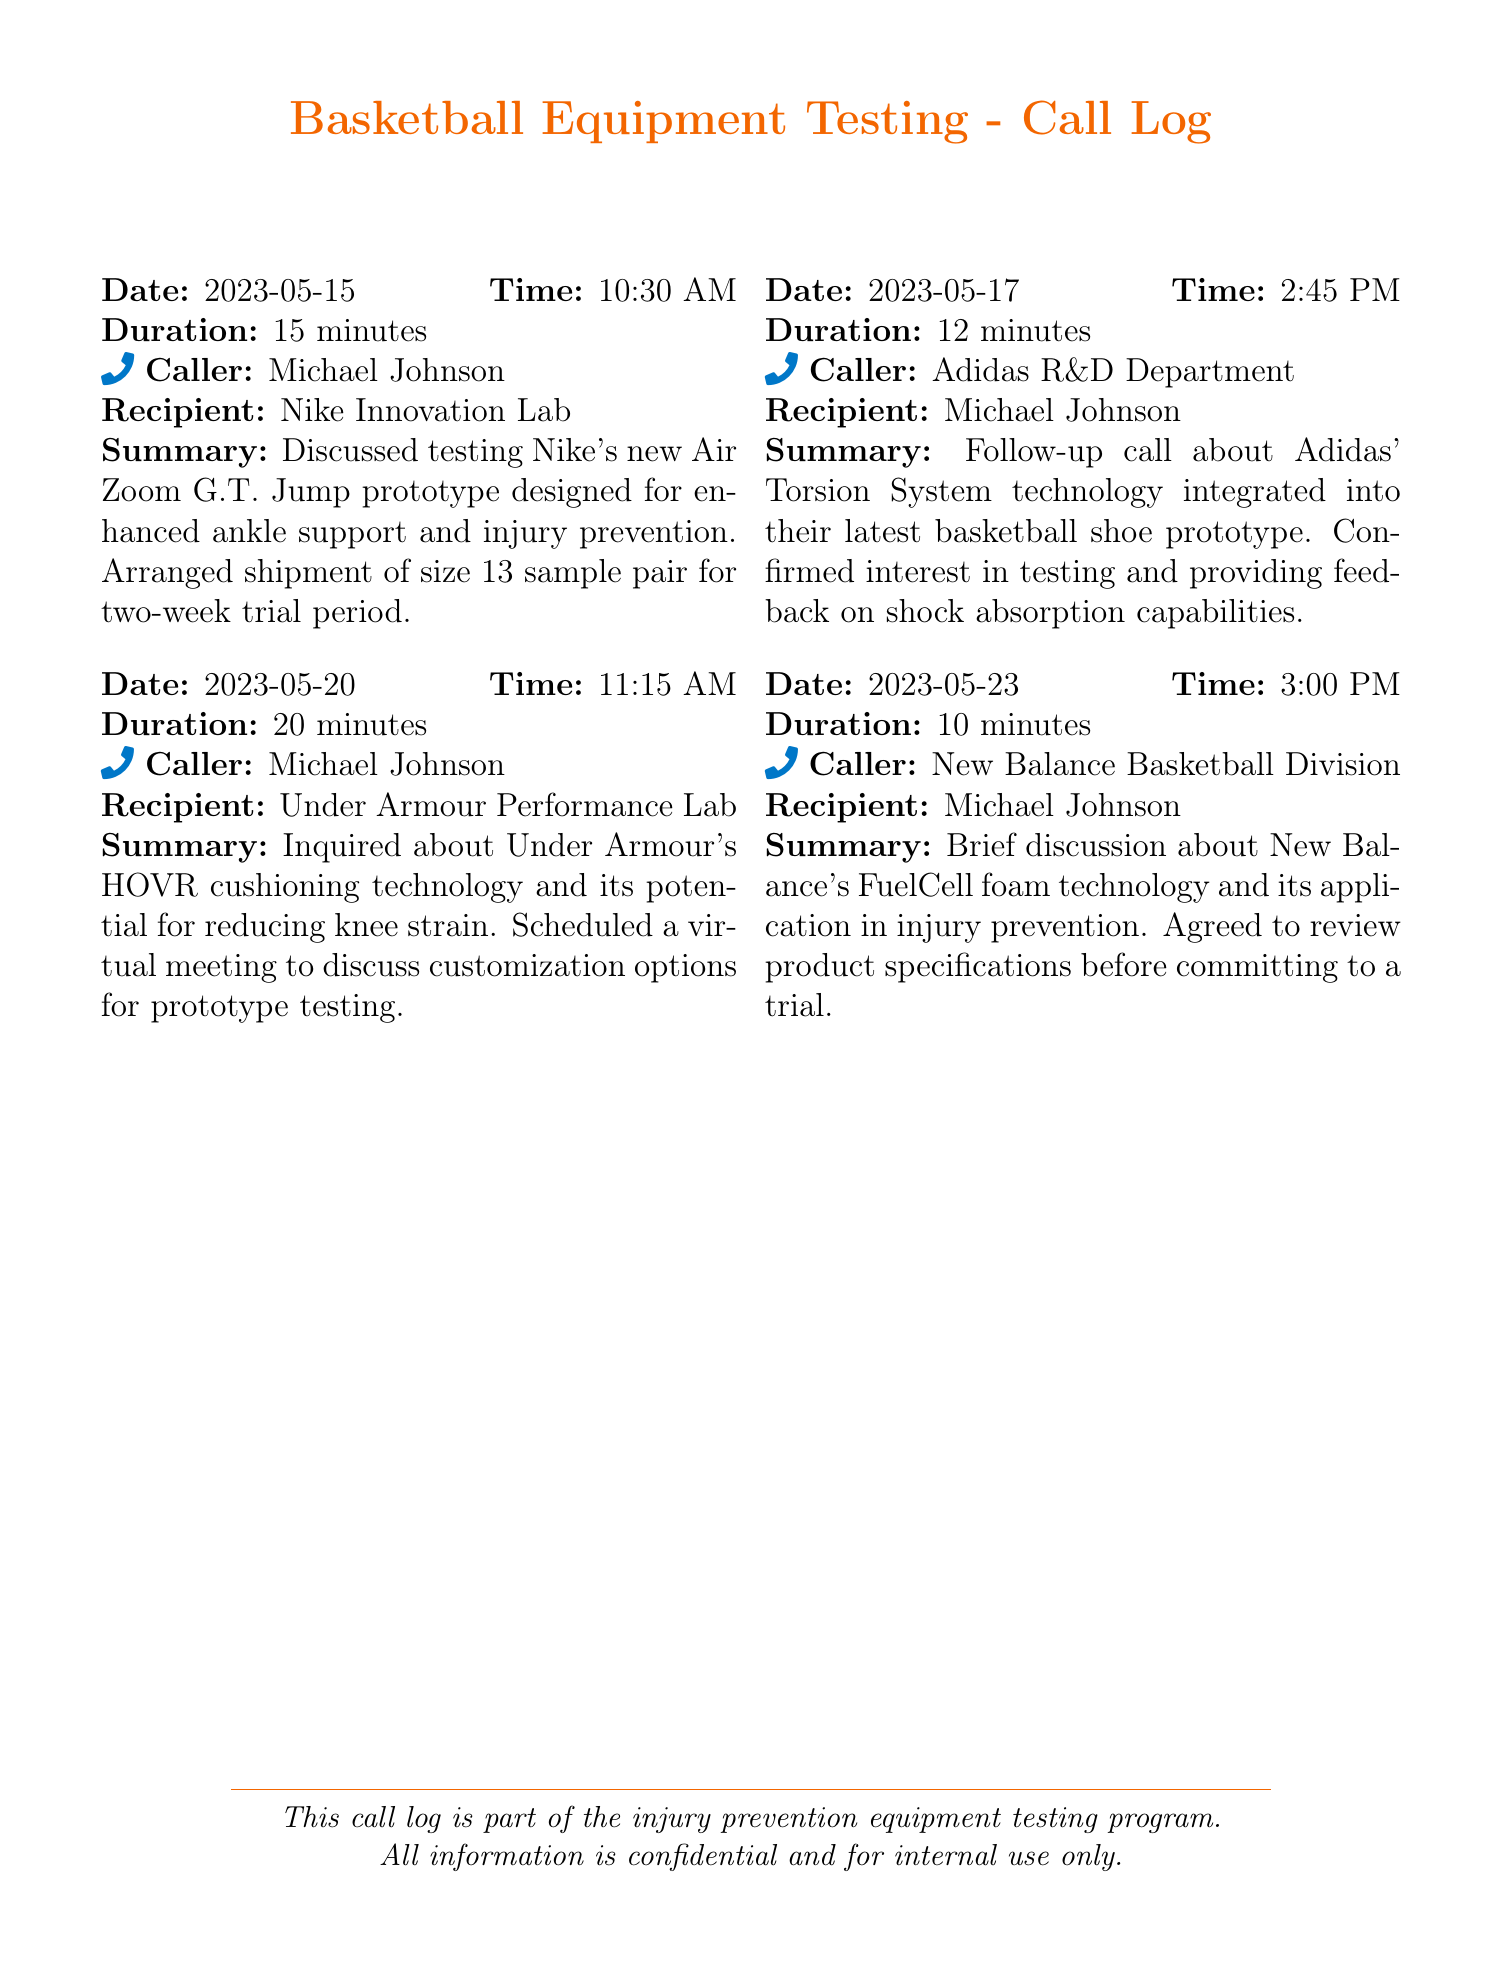What is the date of the first call? The first call occurred on 2023-05-15, which is listed at the top of the first entry.
Answer: 2023-05-15 Who called the Adidas R&D Department? The document indicates that Michael Johnson was the caller for the second entry.
Answer: Michael Johnson What technology did Under Armour discuss? The summary of the third call mentions Under Armour's HOVR cushioning technology.
Answer: HOVR cushioning technology How long was the call with New Balance Basketball Division? The duration of the call with New Balance is specified as 10 minutes in the document.
Answer: 10 minutes What was the purpose of the call with Nike Innovation Lab? The summary of the first call explains that its purpose was to discuss testing a prototype designed for injury prevention.
Answer: Testing prototype basketball shoes What size shoe was arranged for testing in the first call? The first entry clearly states that the size arranged for the sample was size 13.
Answer: Size 13 When was the virtual meeting scheduled with Under Armour? The document does not provide a specific date for the virtual meeting, just that it was scheduled.
Answer: Not specified What type of product specification was reviewed with New Balance? The discussion revolved around product specifications related to FuelCell foam technology.
Answer: FuelCell foam technology How many minutes did the call with Adidas last? The duration of the call with Adidas is mentioned as 12 minutes.
Answer: 12 minutes 